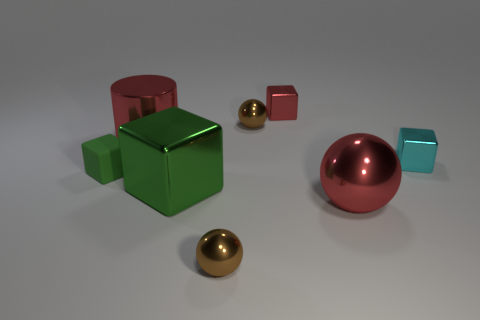Is the color of the large metallic block the same as the big shiny thing on the left side of the big green block?
Make the answer very short. No. Is the number of brown shiny cylinders greater than the number of green metal things?
Provide a succinct answer. No. There is a red object that is the same shape as the big green thing; what is its size?
Offer a very short reply. Small. Does the red sphere have the same material as the large object behind the small cyan object?
Offer a terse response. Yes. What number of objects are either tiny purple matte balls or small cyan shiny things?
Make the answer very short. 1. Does the sphere behind the small cyan metallic block have the same size as the metallic sphere that is in front of the big metal sphere?
Offer a very short reply. Yes. What number of spheres are either cyan shiny things or tiny matte things?
Your answer should be very brief. 0. Are there any brown objects?
Your answer should be very brief. Yes. Are there any other things that are the same shape as the green metal object?
Offer a terse response. Yes. Is the color of the small rubber block the same as the big ball?
Offer a terse response. No. 